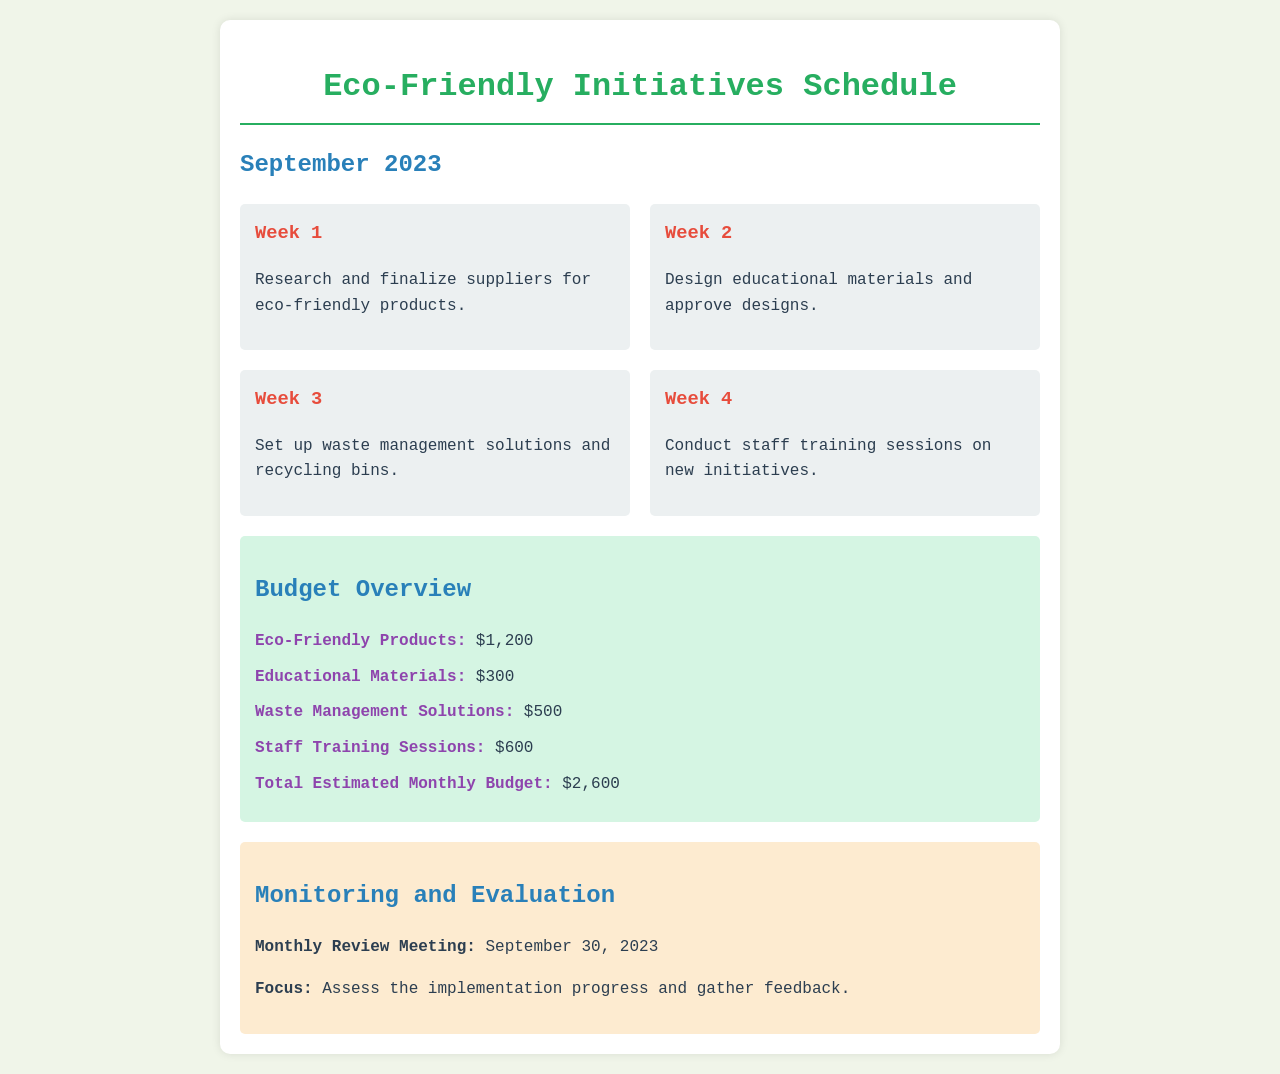What is the total estimated monthly budget? The total estimated monthly budget is specified in the budget overview section, which sums up all the individual budget items.
Answer: $2,600 When is the monthly review meeting scheduled? The date of the monthly review meeting is listed under the monitoring and evaluation section.
Answer: September 30, 2023 What is the budget for eco-friendly products? The budget for eco-friendly products is provided in the budget overview section.
Answer: $1,200 Which week is dedicated to staff training sessions? The schedule outlines the activities for each week, indicating which week will focus on staff training.
Answer: Week 4 What is the focus of the monthly review meeting? The focus of the monthly review meeting is stated under the monitoring and evaluation section, detailing what will be assessed.
Answer: Assess the implementation progress and gather feedback How much is allocated for waste management solutions? The allocation for waste management solutions can be found in the budget overview section.
Answer: $500 What activity takes place in Week 3? Each week has a specific activity listed, highlighting what will occur during Week 3.
Answer: Set up waste management solutions and recycling bins 